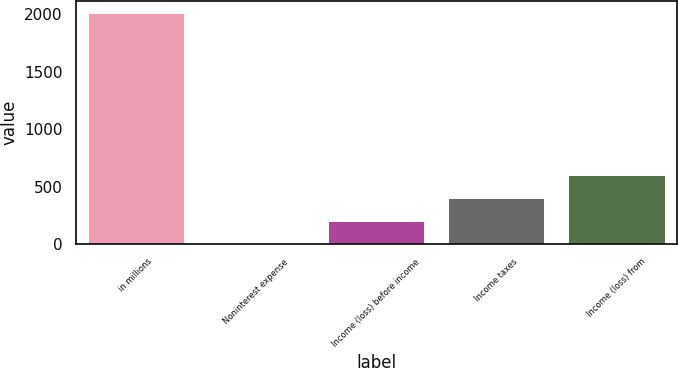Convert chart. <chart><loc_0><loc_0><loc_500><loc_500><bar_chart><fcel>in millions<fcel>Noninterest expense<fcel>Income (loss) before income<fcel>Income taxes<fcel>Income (loss) from<nl><fcel>2013<fcel>1<fcel>202.2<fcel>403.4<fcel>604.6<nl></chart> 